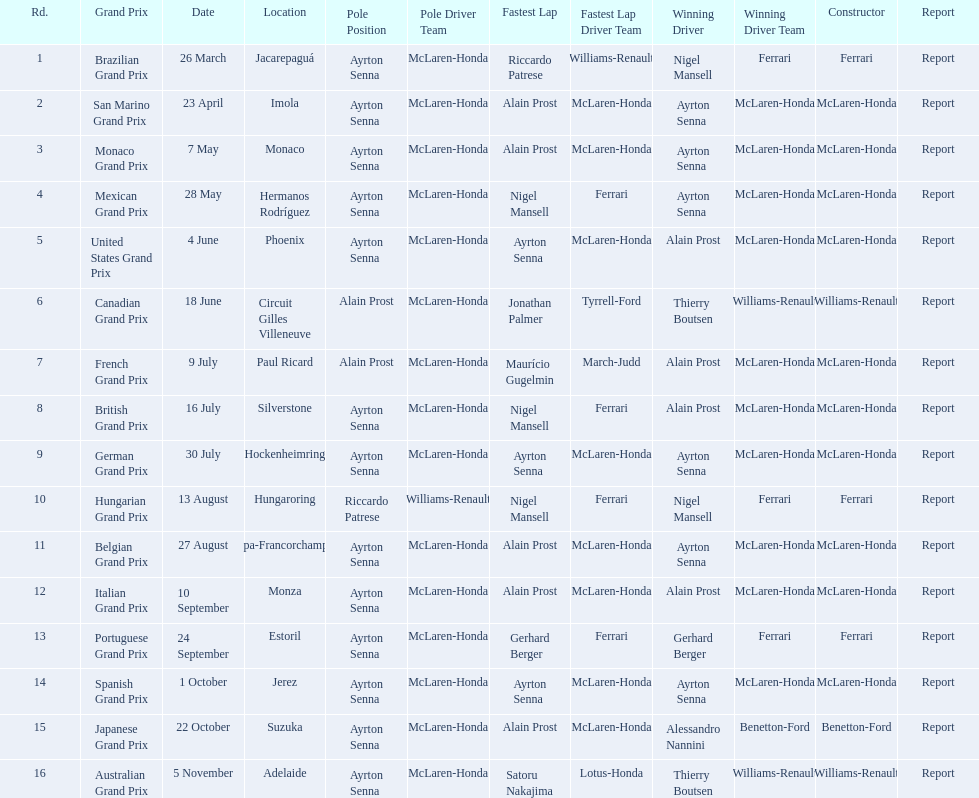How many did alain prost have the fastest lap? 5. Help me parse the entirety of this table. {'header': ['Rd.', 'Grand Prix', 'Date', 'Location', 'Pole Position', 'Pole Driver Team', 'Fastest Lap', 'Fastest Lap Driver Team', 'Winning Driver', 'Winning Driver Team', 'Constructor', 'Report'], 'rows': [['1', 'Brazilian Grand Prix', '26 March', 'Jacarepaguá', 'Ayrton Senna', 'McLaren-Honda', 'Riccardo Patrese', 'Williams-Renault', 'Nigel Mansell', 'Ferrari', 'Ferrari', 'Report'], ['2', 'San Marino Grand Prix', '23 April', 'Imola', 'Ayrton Senna', 'McLaren-Honda', 'Alain Prost', 'McLaren-Honda', 'Ayrton Senna', 'McLaren-Honda', 'McLaren-Honda', 'Report'], ['3', 'Monaco Grand Prix', '7 May', 'Monaco', 'Ayrton Senna', 'McLaren-Honda', 'Alain Prost', 'McLaren-Honda', 'Ayrton Senna', 'McLaren-Honda', 'McLaren-Honda', 'Report'], ['4', 'Mexican Grand Prix', '28 May', 'Hermanos Rodríguez', 'Ayrton Senna', 'McLaren-Honda', 'Nigel Mansell', 'Ferrari', 'Ayrton Senna', 'McLaren-Honda', 'McLaren-Honda', 'Report'], ['5', 'United States Grand Prix', '4 June', 'Phoenix', 'Ayrton Senna', 'McLaren-Honda', 'Ayrton Senna', 'McLaren-Honda', 'Alain Prost', 'McLaren-Honda', 'McLaren-Honda', 'Report'], ['6', 'Canadian Grand Prix', '18 June', 'Circuit Gilles Villeneuve', 'Alain Prost', 'McLaren-Honda', 'Jonathan Palmer', 'Tyrrell-Ford', 'Thierry Boutsen', 'Williams-Renault', 'Williams-Renault', 'Report'], ['7', 'French Grand Prix', '9 July', 'Paul Ricard', 'Alain Prost', 'McLaren-Honda', 'Maurício Gugelmin', 'March-Judd', 'Alain Prost', 'McLaren-Honda', 'McLaren-Honda', 'Report'], ['8', 'British Grand Prix', '16 July', 'Silverstone', 'Ayrton Senna', 'McLaren-Honda', 'Nigel Mansell', 'Ferrari', 'Alain Prost', 'McLaren-Honda', 'McLaren-Honda', 'Report'], ['9', 'German Grand Prix', '30 July', 'Hockenheimring', 'Ayrton Senna', 'McLaren-Honda', 'Ayrton Senna', 'McLaren-Honda', 'Ayrton Senna', 'McLaren-Honda', 'McLaren-Honda', 'Report'], ['10', 'Hungarian Grand Prix', '13 August', 'Hungaroring', 'Riccardo Patrese', 'Williams-Renault', 'Nigel Mansell', 'Ferrari', 'Nigel Mansell', 'Ferrari', 'Ferrari', 'Report'], ['11', 'Belgian Grand Prix', '27 August', 'Spa-Francorchamps', 'Ayrton Senna', 'McLaren-Honda', 'Alain Prost', 'McLaren-Honda', 'Ayrton Senna', 'McLaren-Honda', 'McLaren-Honda', 'Report'], ['12', 'Italian Grand Prix', '10 September', 'Monza', 'Ayrton Senna', 'McLaren-Honda', 'Alain Prost', 'McLaren-Honda', 'Alain Prost', 'McLaren-Honda', 'McLaren-Honda', 'Report'], ['13', 'Portuguese Grand Prix', '24 September', 'Estoril', 'Ayrton Senna', 'McLaren-Honda', 'Gerhard Berger', 'Ferrari', 'Gerhard Berger', 'Ferrari', 'Ferrari', 'Report'], ['14', 'Spanish Grand Prix', '1 October', 'Jerez', 'Ayrton Senna', 'McLaren-Honda', 'Ayrton Senna', 'McLaren-Honda', 'Ayrton Senna', 'McLaren-Honda', 'McLaren-Honda', 'Report'], ['15', 'Japanese Grand Prix', '22 October', 'Suzuka', 'Ayrton Senna', 'McLaren-Honda', 'Alain Prost', 'McLaren-Honda', 'Alessandro Nannini', 'Benetton-Ford', 'Benetton-Ford', 'Report'], ['16', 'Australian Grand Prix', '5 November', 'Adelaide', 'Ayrton Senna', 'McLaren-Honda', 'Satoru Nakajima', 'Lotus-Honda', 'Thierry Boutsen', 'Williams-Renault', 'Williams-Renault', 'Report']]} 